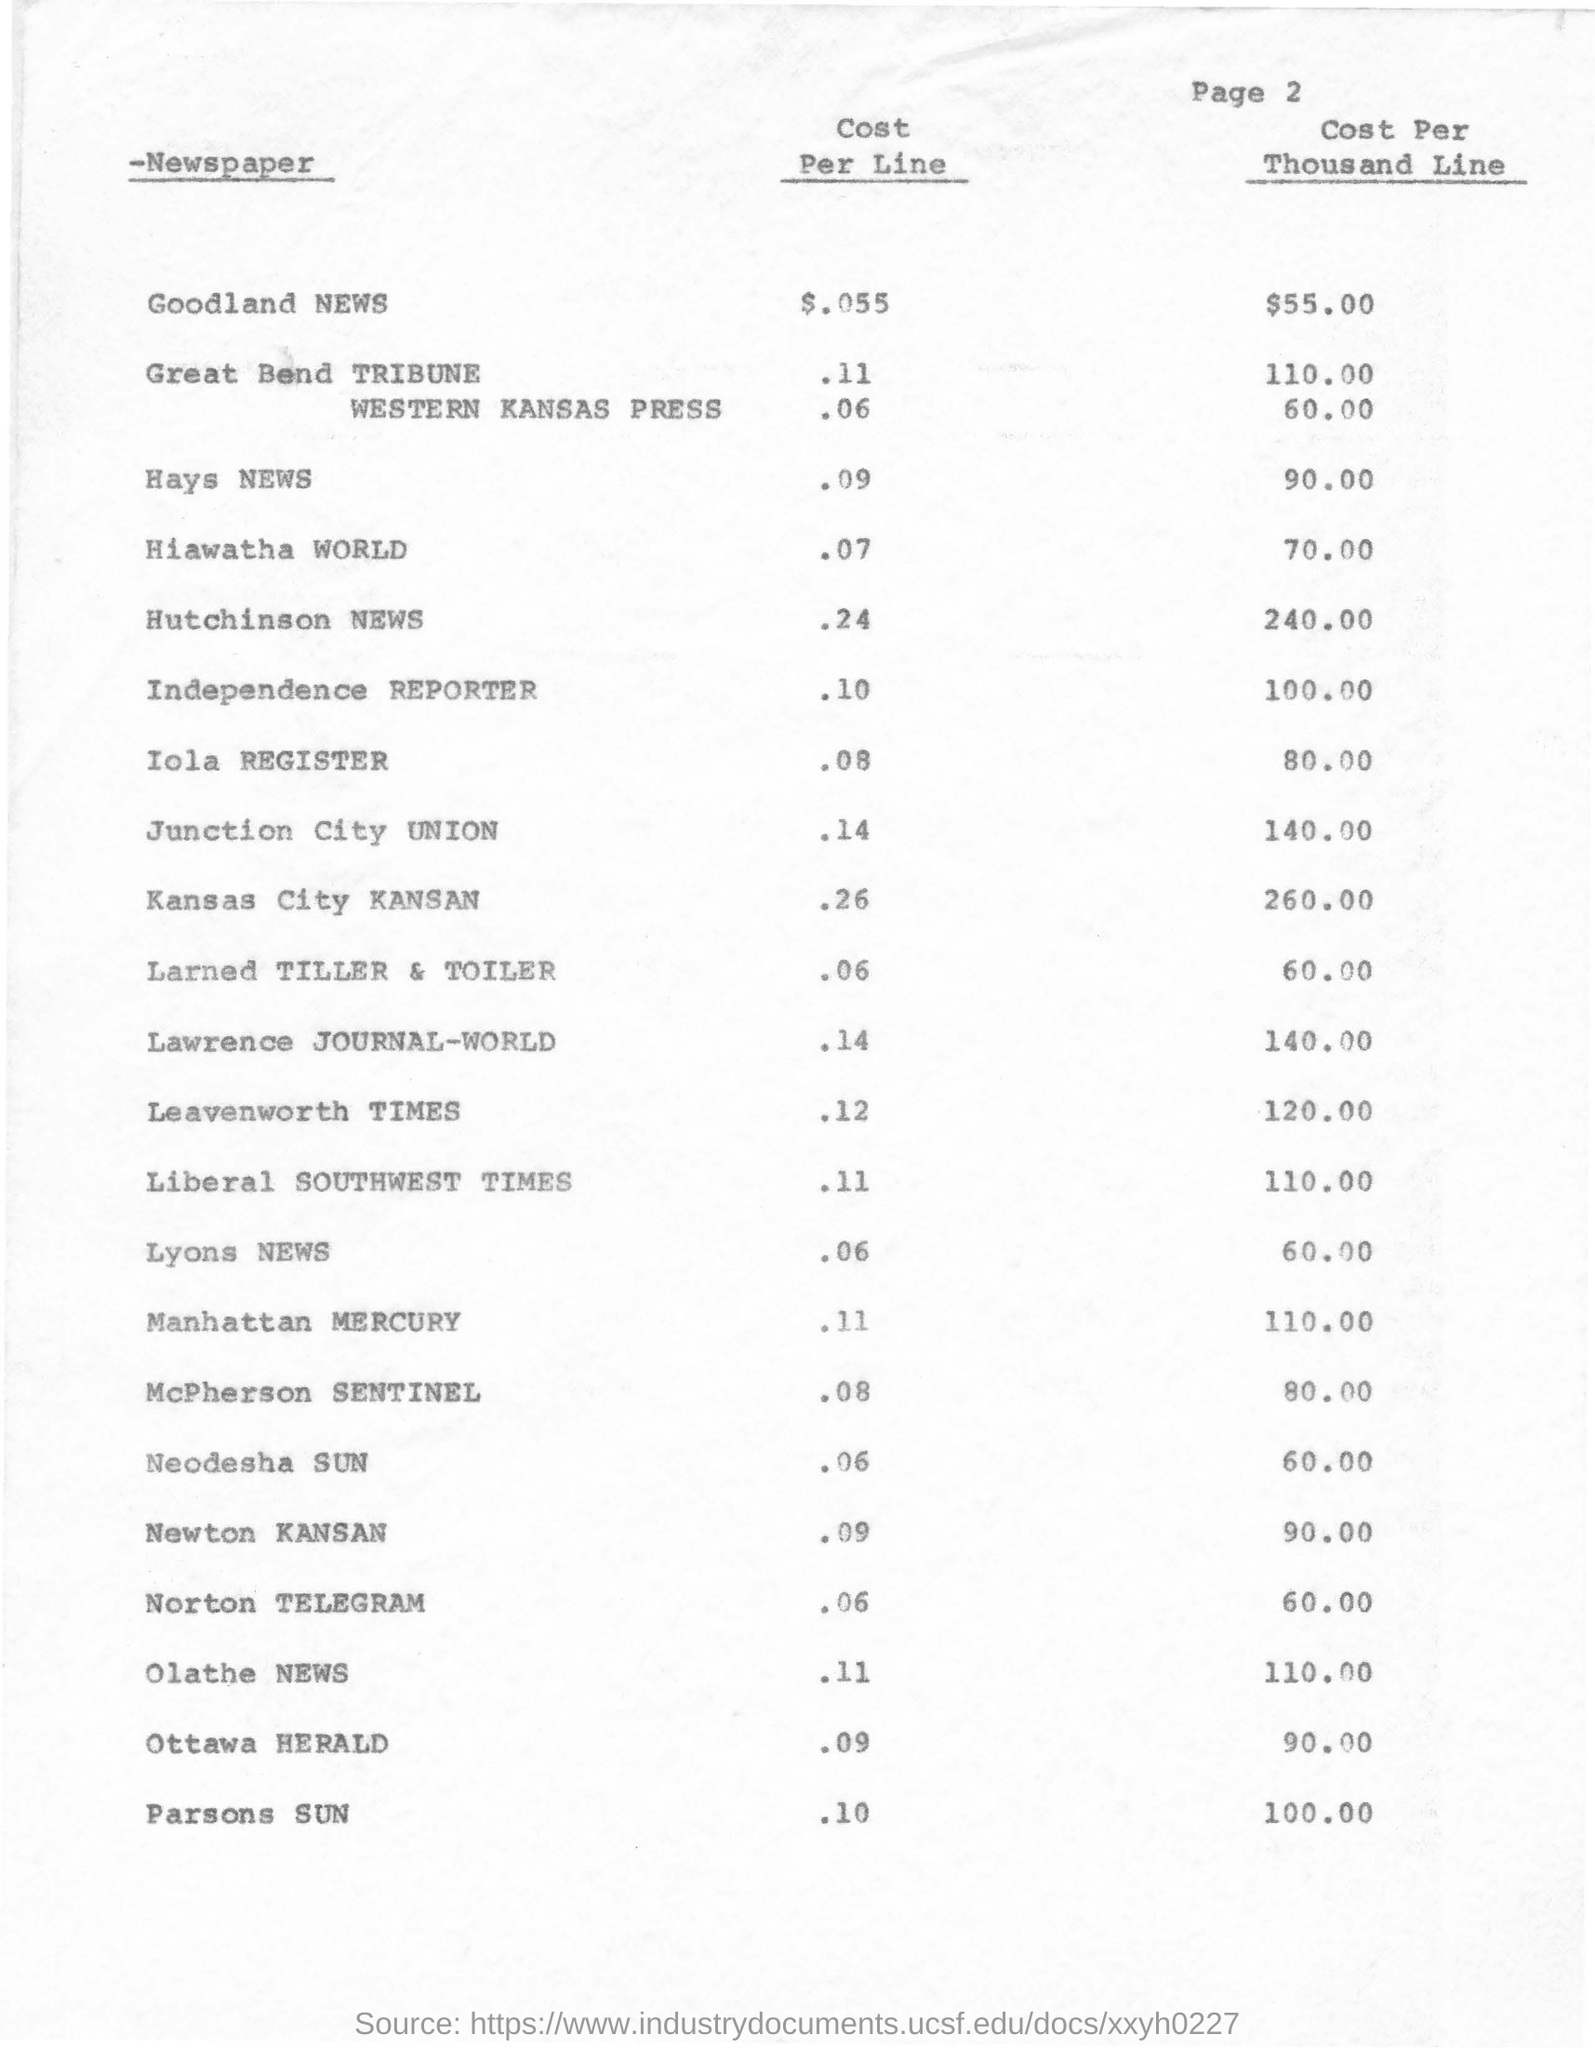What is the Cost Per Line for Goodland NEWS?
Give a very brief answer. $.055. What is the Cost Per Thousand Line for Hays NEWS?
Give a very brief answer. 90.00. What is the page no mentioned in this document?
Provide a succinct answer. 2. What is the Cost Per Line for Lyons NEWS?
Your response must be concise. .06. Which newspaper has Cost per Thousand Line as $240.00?
Provide a short and direct response. Hutchinson NEWS. 